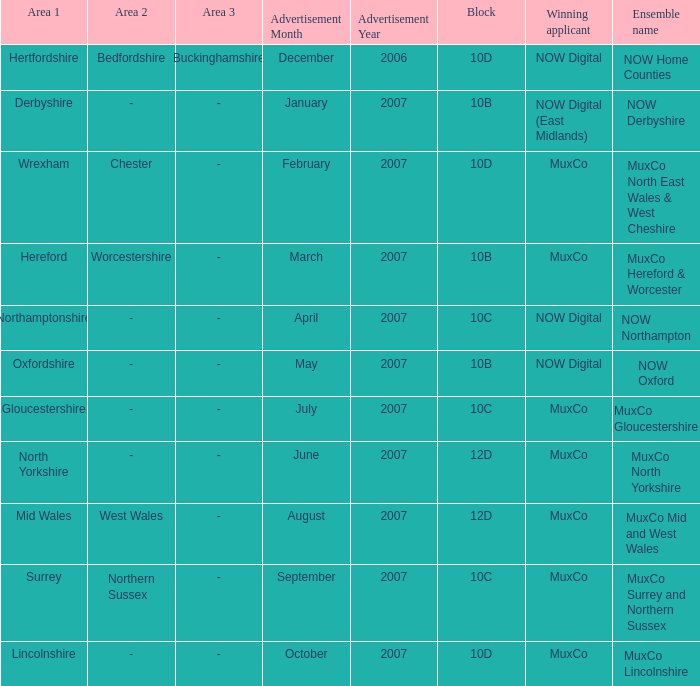What is Oxfordshire Area's Ensemble Name? NOW Oxford. 